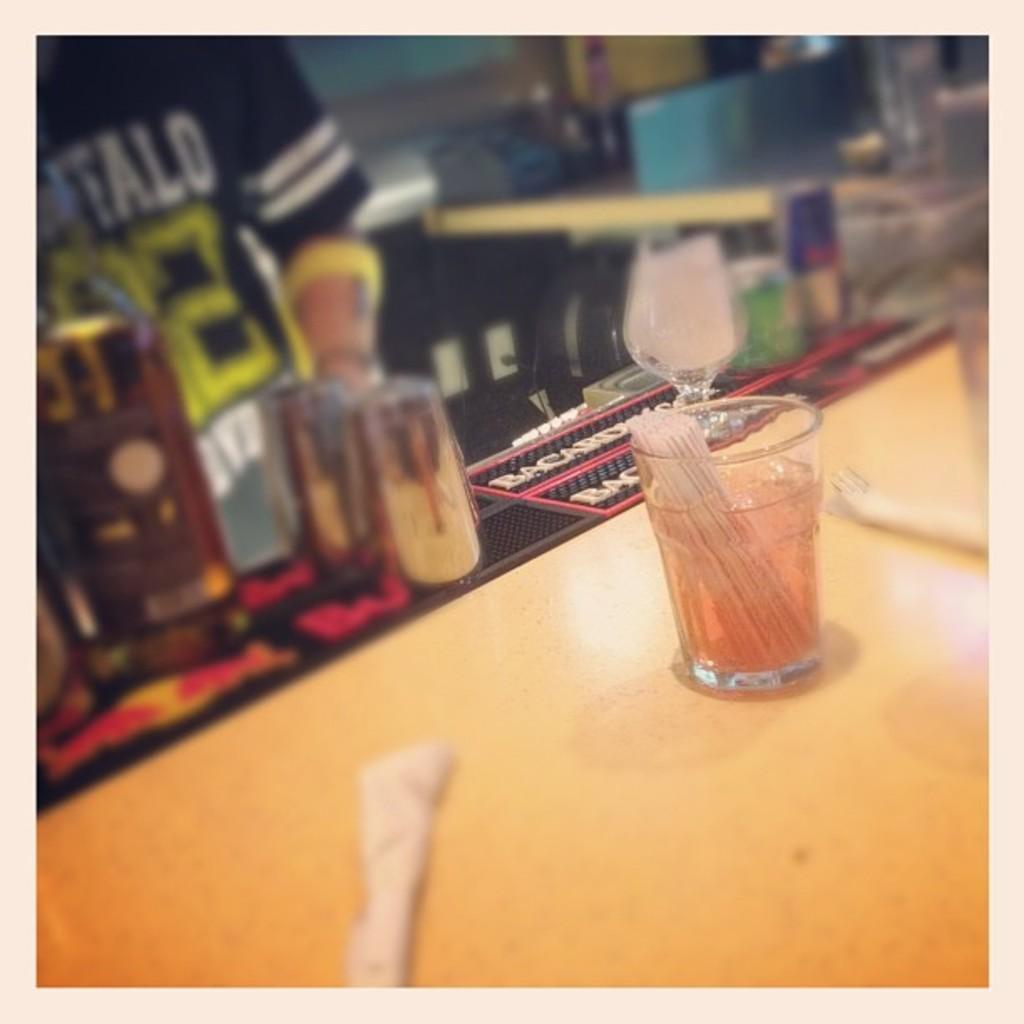Could you give a brief overview of what you see in this image? In the image we can see the glass, in the glass there is a liquid. Here we can see wooden surface and a person wearing clothes. Here we can see wine glass and the background is blurred. 